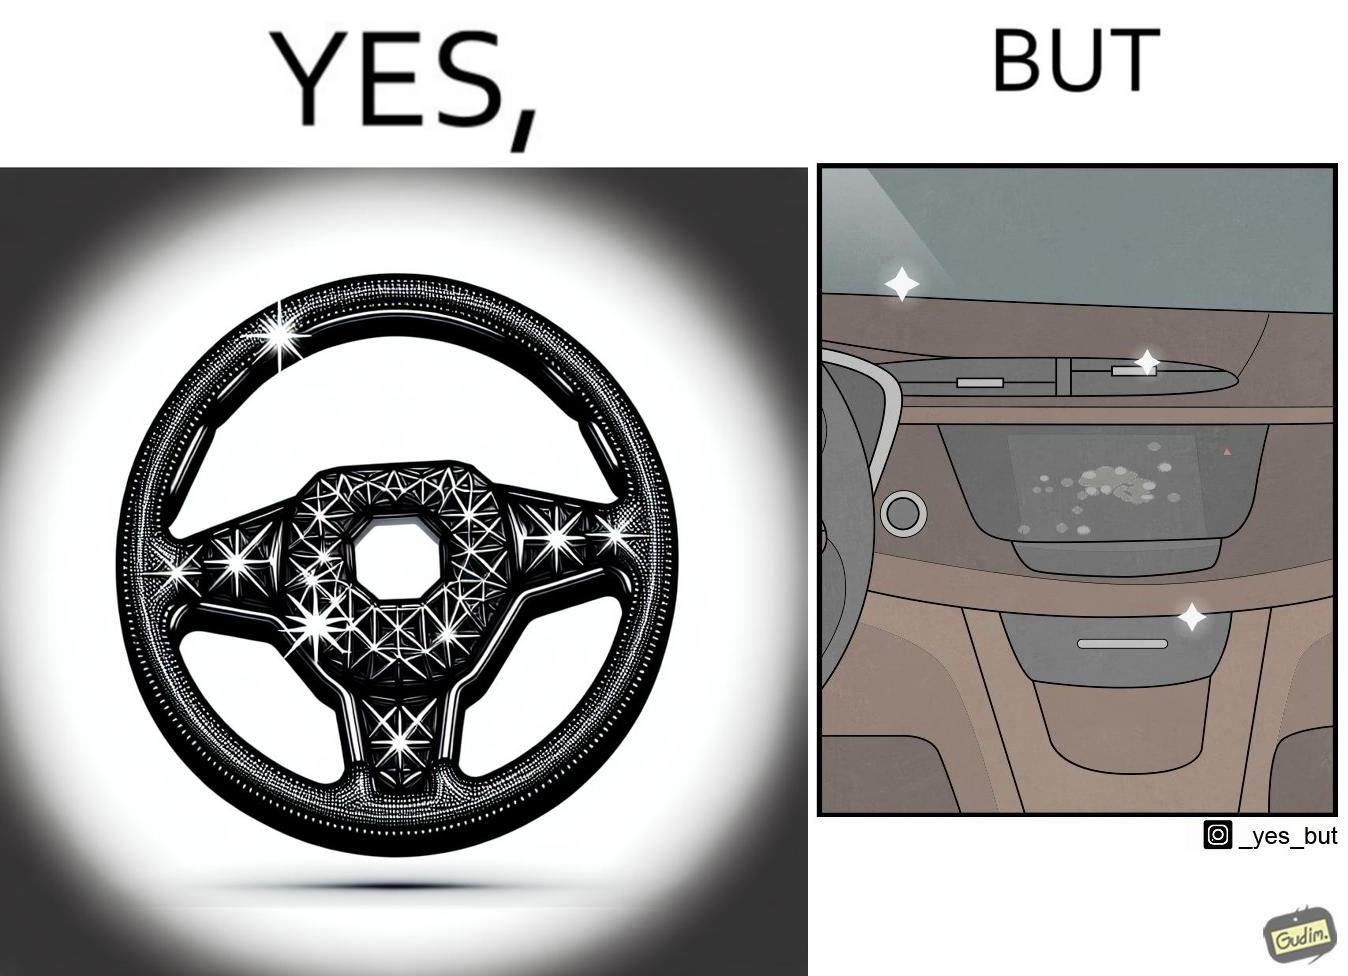What is the satirical meaning behind this image? The dashboard and steering wheel of the car look sparkling clean, but the greasy fingerprints on the touch panel reduce the appeal of the dashboard. 